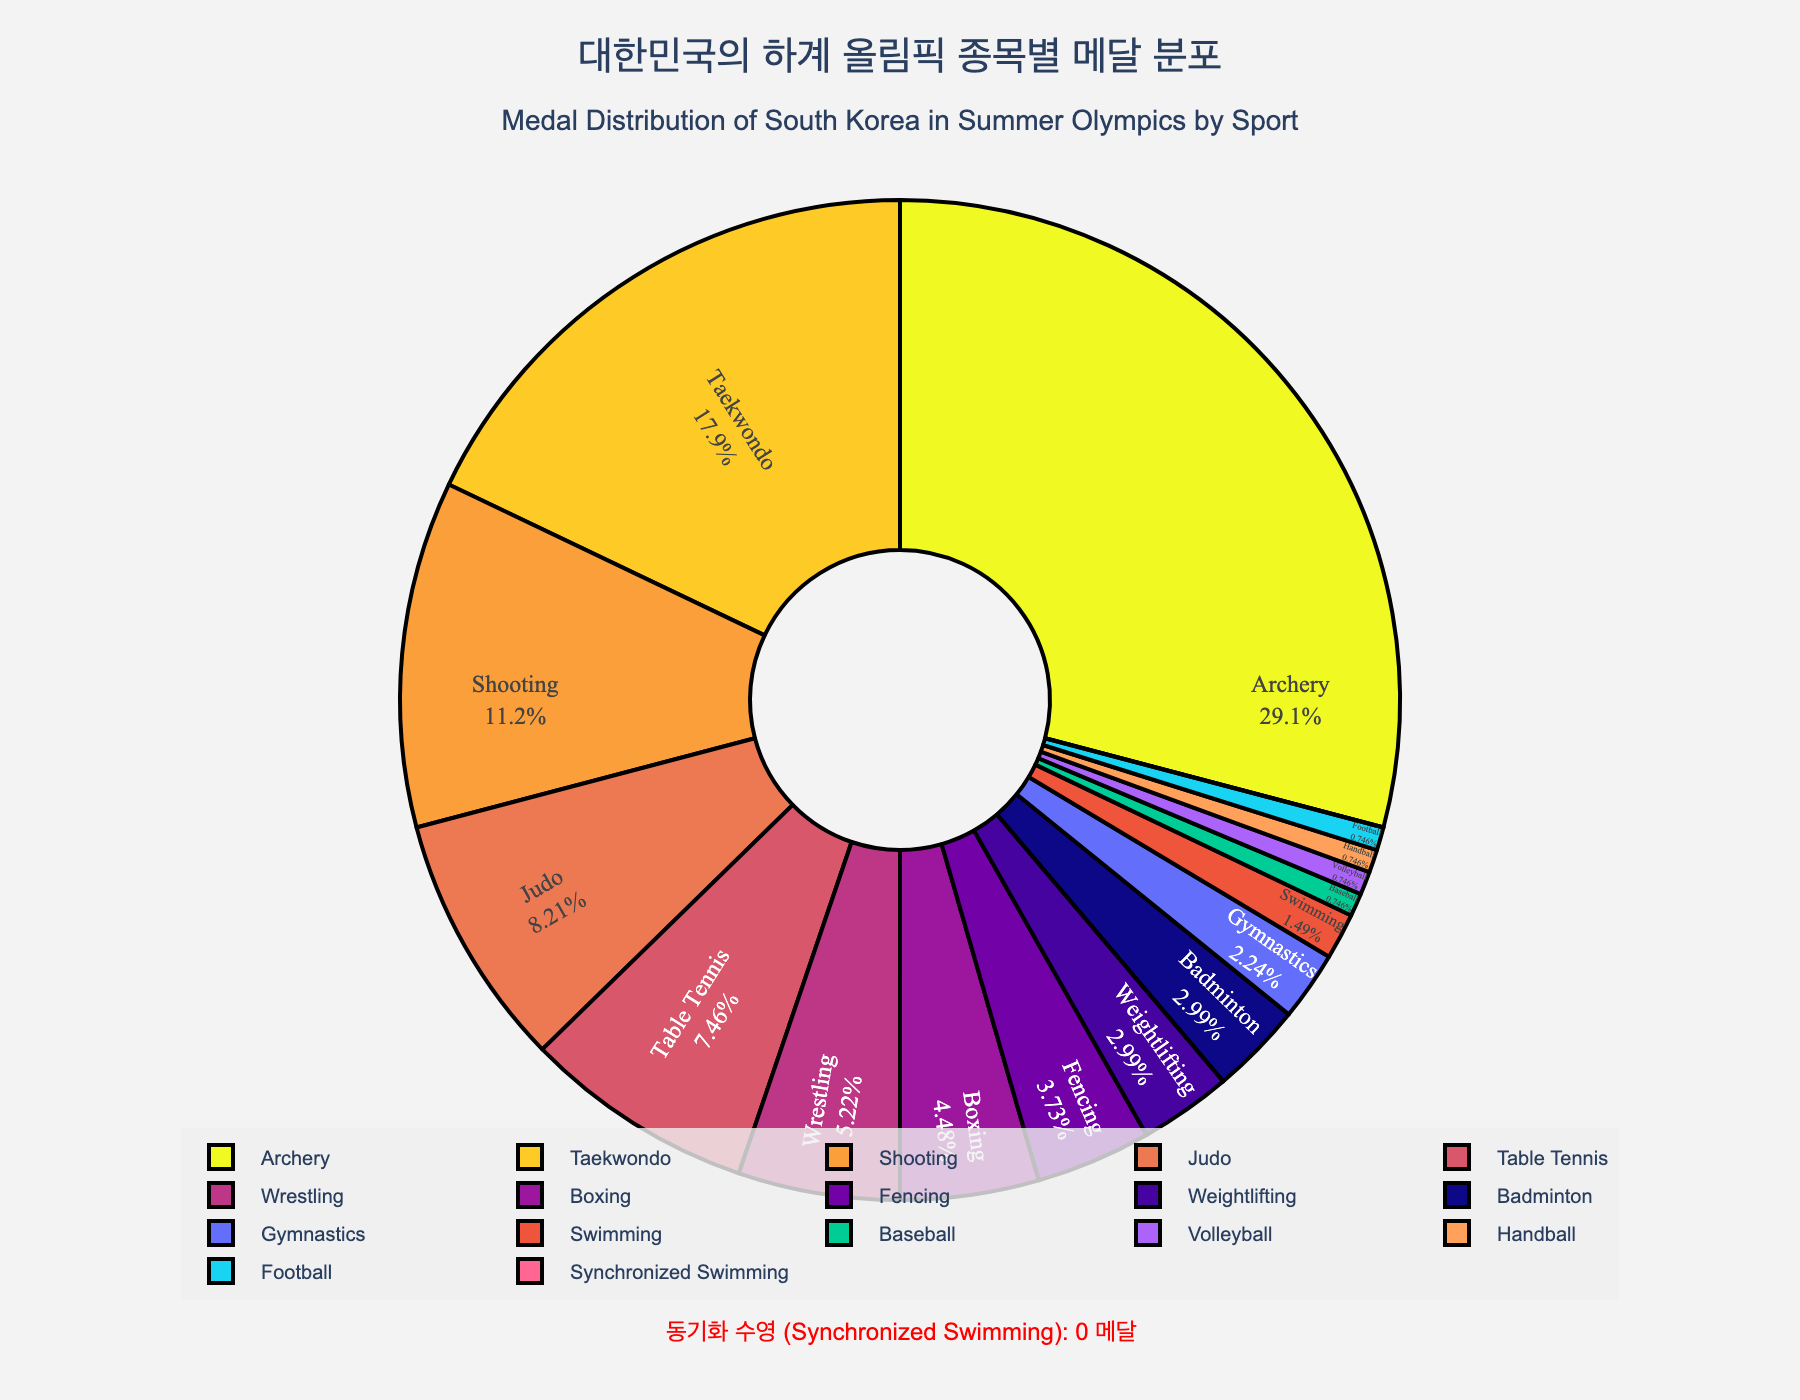what sport has won the most medals for South Korea in the Summer Olympics? Look at the figure's labels for each slice and observe which sport has the largest slice. Archery has the largest slice.
Answer: Archery What percentage of medals has South Korea won in Shooting compared to Judo? Observe the figure to identify the percentage values for Shooting and Judo, then compare them.
Answer: Shooting has more than Judo How many more medals has Taekwondo won than Table Tennis? Refer to the numbers inside the Taekwondo and Table Tennis sections. Taekwondo has 24 medals, Table Tennis has 10 medals. 24 - 10 = 14.
Answer: 14 Which three sports have won more than 20 medals each? Identify the slices where the number of medals is greater than 20 by examining the numbers on the chart. Archery with 39 medals, Taekwondo with 24 medals.
Answer: Archery, Taekwondo Which sport is specifically mentioned to have no medals, highlighted separately? Look for the text annotation placed separately to emphasize no medals won. Synchronized Swimming is highlighted with a note mentioning "0 medals".
Answer: Synchronized Swimming 